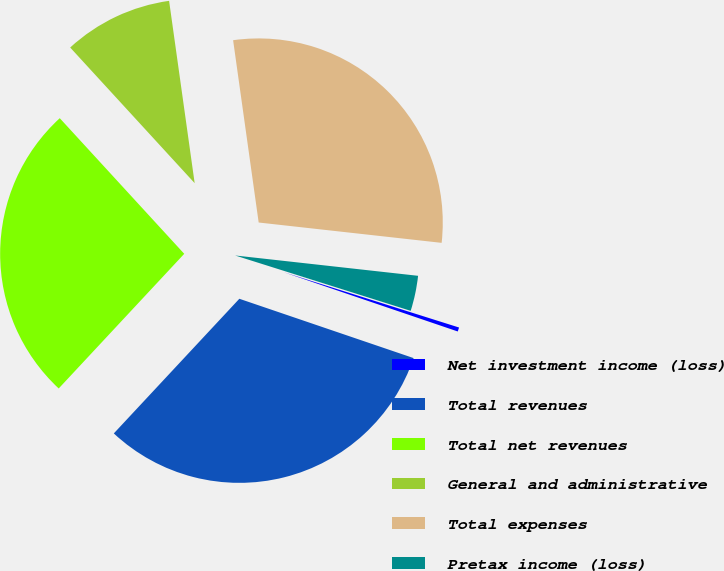Convert chart. <chart><loc_0><loc_0><loc_500><loc_500><pie_chart><fcel>Net investment income (loss)<fcel>Total revenues<fcel>Total net revenues<fcel>General and administrative<fcel>Total expenses<fcel>Pretax income (loss)<nl><fcel>0.36%<fcel>31.72%<fcel>26.24%<fcel>9.6%<fcel>28.98%<fcel>3.1%<nl></chart> 